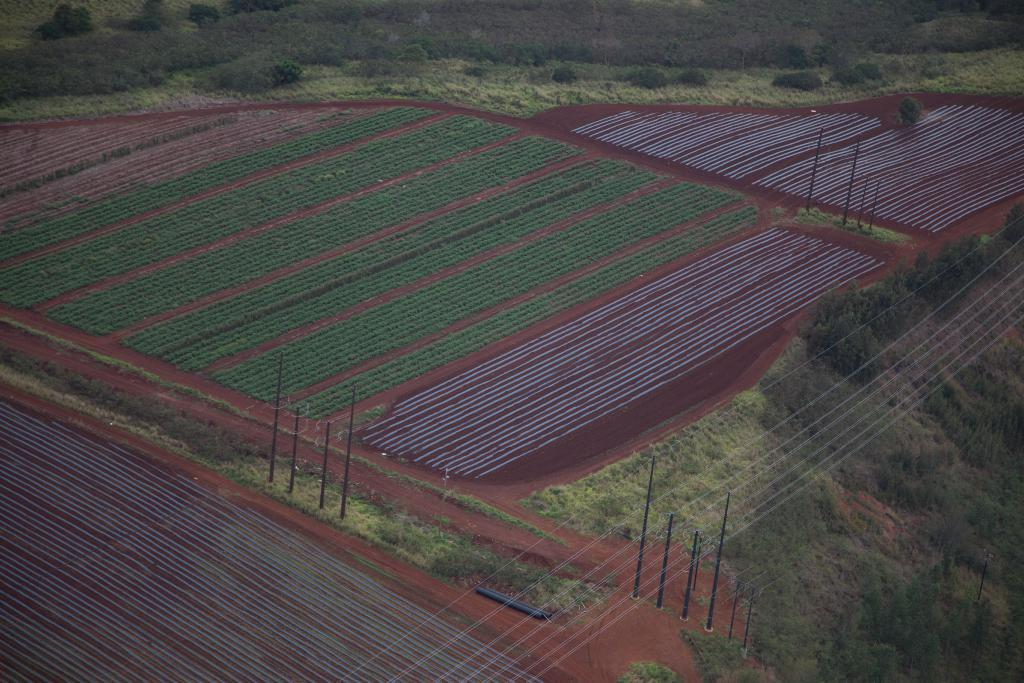What type of landscape is depicted in the image? The image features fields. What can be seen in the background of the image? There are trees and poles in the background of the image. Are there any additional structures or elements in the background? Yes, there are wires in the background of the image. How many slaves can be seen working in the fields in the image? There are no slaves present in the image; it features fields with no visible human activity. Is there a park visible in the image? There is no park present in the image; it features fields and background elements such as trees, poles, and wires. 